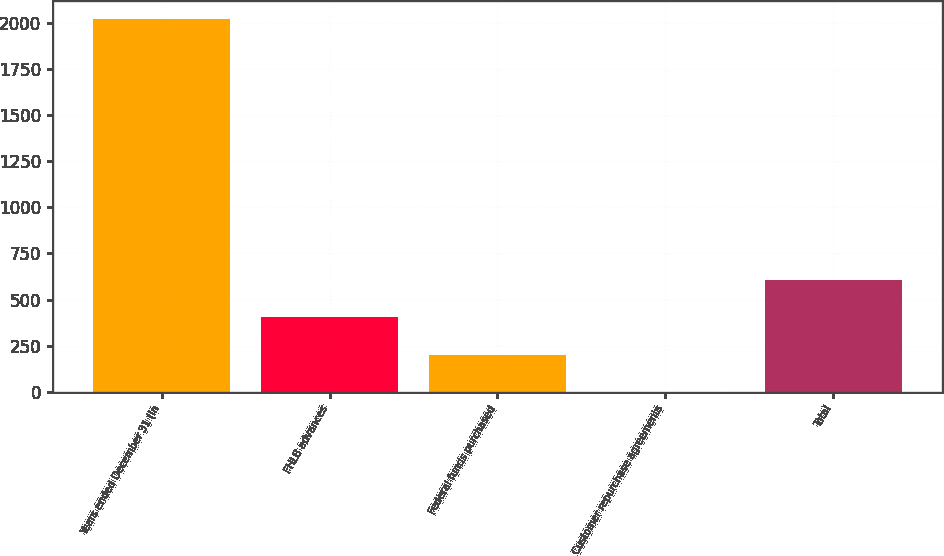Convert chart. <chart><loc_0><loc_0><loc_500><loc_500><bar_chart><fcel>Years ended December 31 (in<fcel>FHLB advances<fcel>Federal funds purchased<fcel>Customer repurchase agreements<fcel>Total<nl><fcel>2018<fcel>404.4<fcel>202.7<fcel>1<fcel>606.1<nl></chart> 